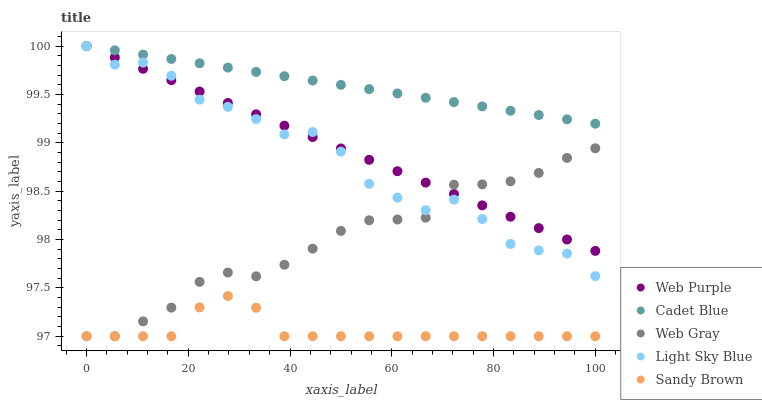Does Sandy Brown have the minimum area under the curve?
Answer yes or no. Yes. Does Cadet Blue have the maximum area under the curve?
Answer yes or no. Yes. Does Web Purple have the minimum area under the curve?
Answer yes or no. No. Does Web Purple have the maximum area under the curve?
Answer yes or no. No. Is Web Purple the smoothest?
Answer yes or no. Yes. Is Light Sky Blue the roughest?
Answer yes or no. Yes. Is Cadet Blue the smoothest?
Answer yes or no. No. Is Cadet Blue the roughest?
Answer yes or no. No. Does Sandy Brown have the lowest value?
Answer yes or no. Yes. Does Web Purple have the lowest value?
Answer yes or no. No. Does Light Sky Blue have the highest value?
Answer yes or no. Yes. Does Web Gray have the highest value?
Answer yes or no. No. Is Sandy Brown less than Cadet Blue?
Answer yes or no. Yes. Is Cadet Blue greater than Web Gray?
Answer yes or no. Yes. Does Sandy Brown intersect Web Gray?
Answer yes or no. Yes. Is Sandy Brown less than Web Gray?
Answer yes or no. No. Is Sandy Brown greater than Web Gray?
Answer yes or no. No. Does Sandy Brown intersect Cadet Blue?
Answer yes or no. No. 